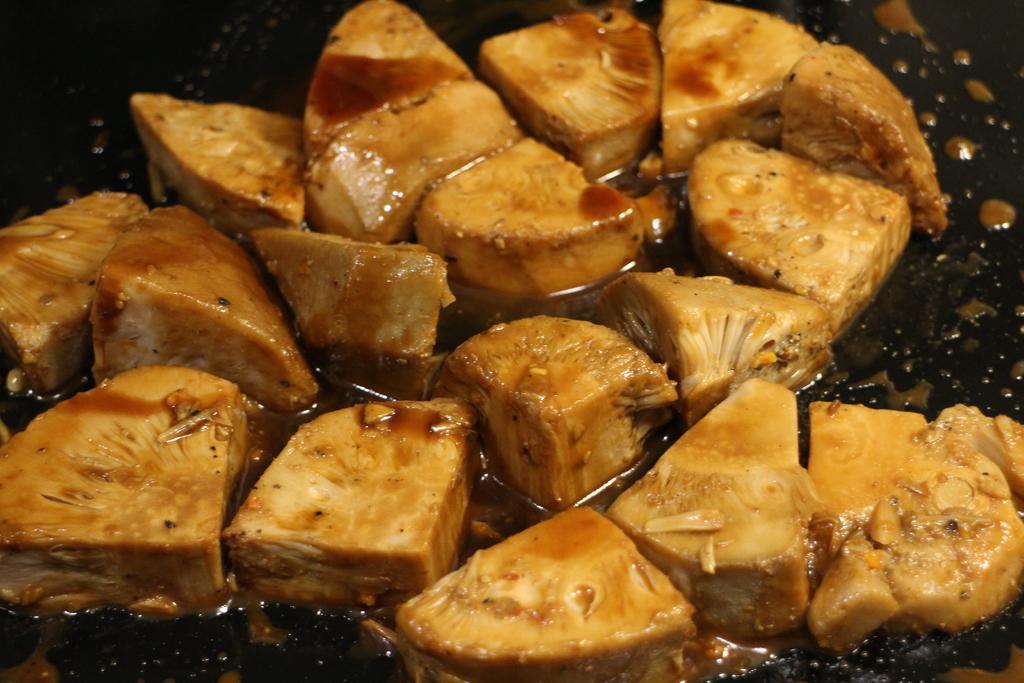In one or two sentences, can you explain what this image depicts? In this image I can see a food is on the black surface.   